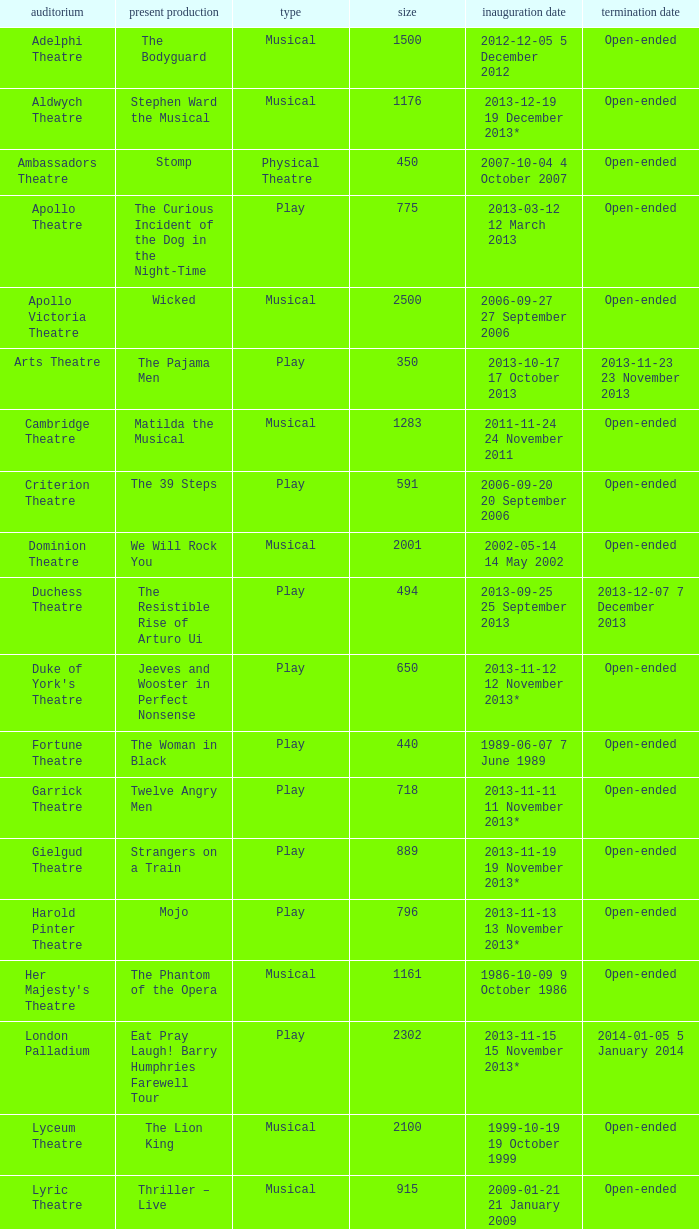What opening date has a capacity of 100? 2013-11-01 1 November 2013. 